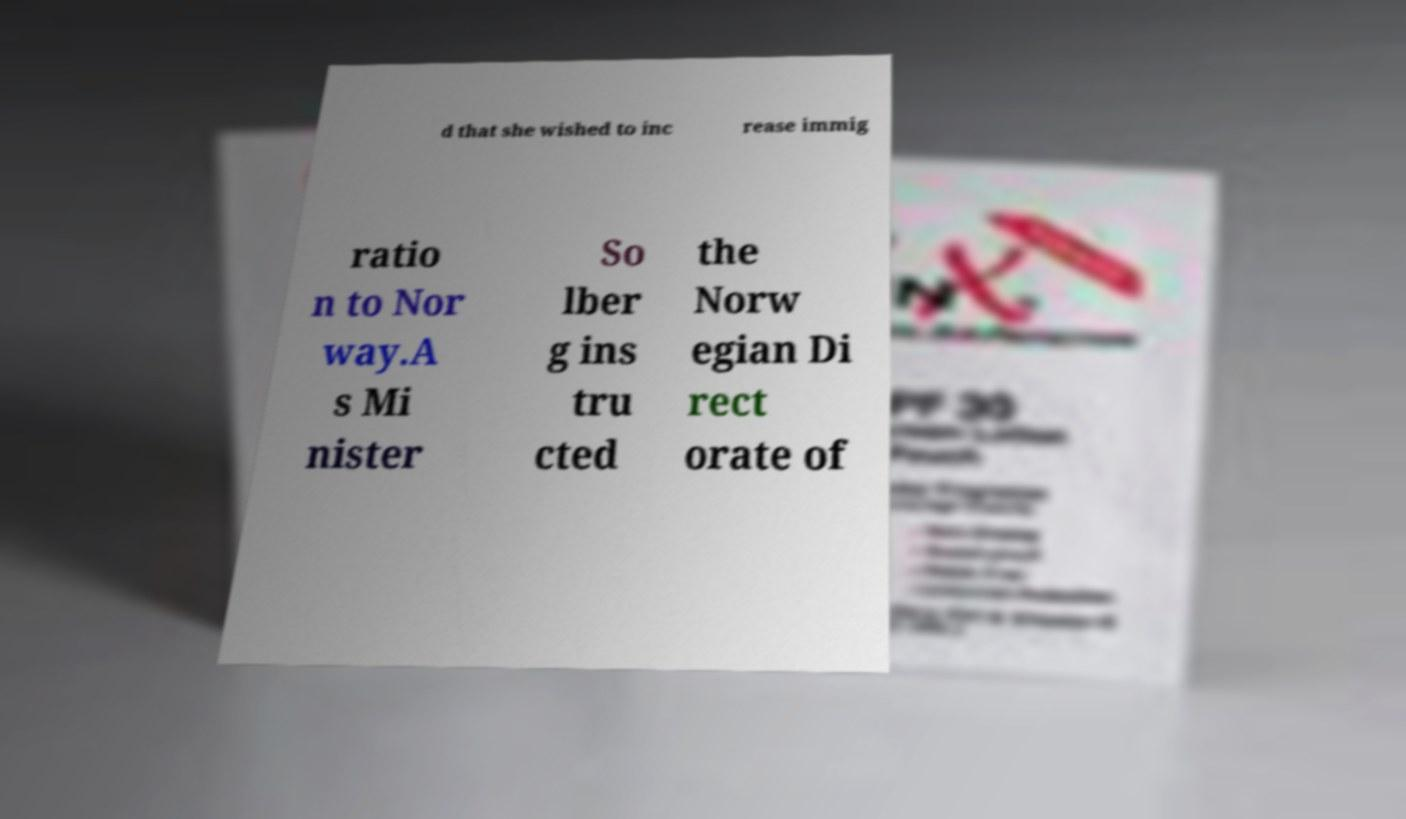For documentation purposes, I need the text within this image transcribed. Could you provide that? d that she wished to inc rease immig ratio n to Nor way.A s Mi nister So lber g ins tru cted the Norw egian Di rect orate of 